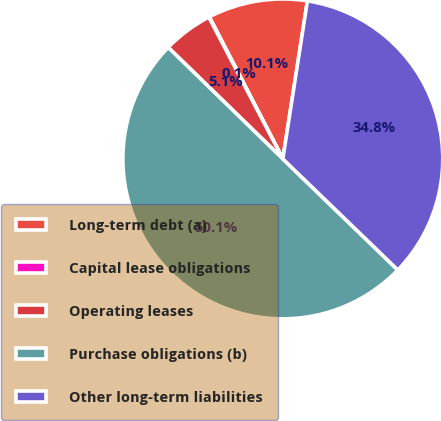Convert chart to OTSL. <chart><loc_0><loc_0><loc_500><loc_500><pie_chart><fcel>Long-term debt (a)<fcel>Capital lease obligations<fcel>Operating leases<fcel>Purchase obligations (b)<fcel>Other long-term liabilities<nl><fcel>10.06%<fcel>0.06%<fcel>5.06%<fcel>50.06%<fcel>34.77%<nl></chart> 